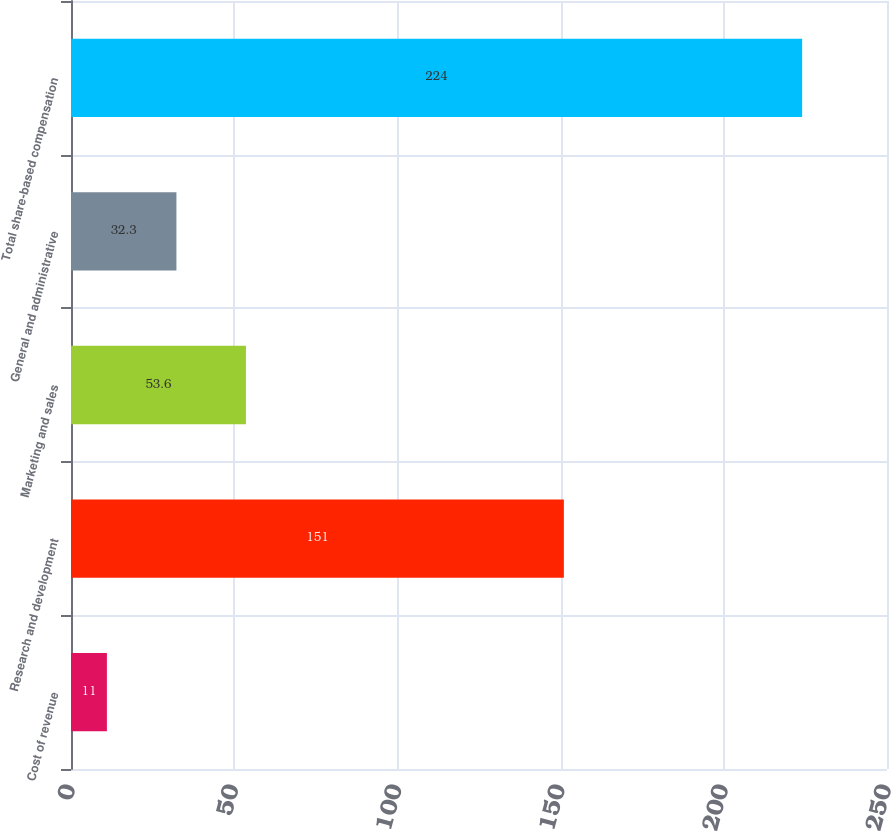Convert chart to OTSL. <chart><loc_0><loc_0><loc_500><loc_500><bar_chart><fcel>Cost of revenue<fcel>Research and development<fcel>Marketing and sales<fcel>General and administrative<fcel>Total share-based compensation<nl><fcel>11<fcel>151<fcel>53.6<fcel>32.3<fcel>224<nl></chart> 